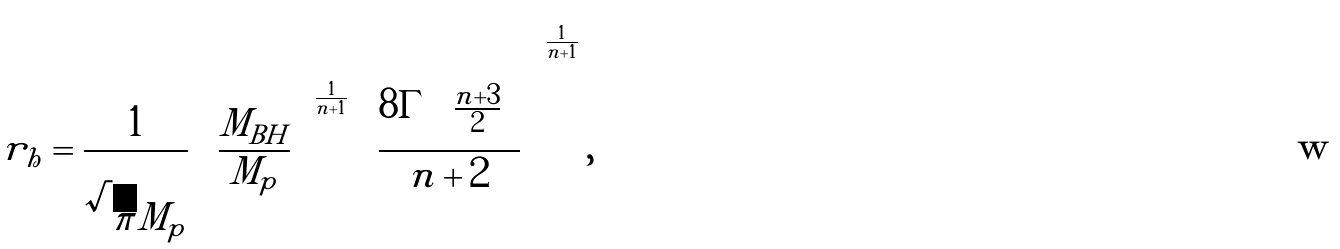Convert formula to latex. <formula><loc_0><loc_0><loc_500><loc_500>r _ { h } = \frac { 1 } { \sqrt { \pi } M _ { p } } \left ( \frac { M _ { B H } } { M _ { p } } \right ) ^ { \frac { 1 } { n + 1 } } \left ( \frac { 8 \Gamma \left ( \frac { n + 3 } { 2 } \right ) } { n + 2 } \right ) ^ { \frac { 1 } { n + 1 } } ,</formula> 